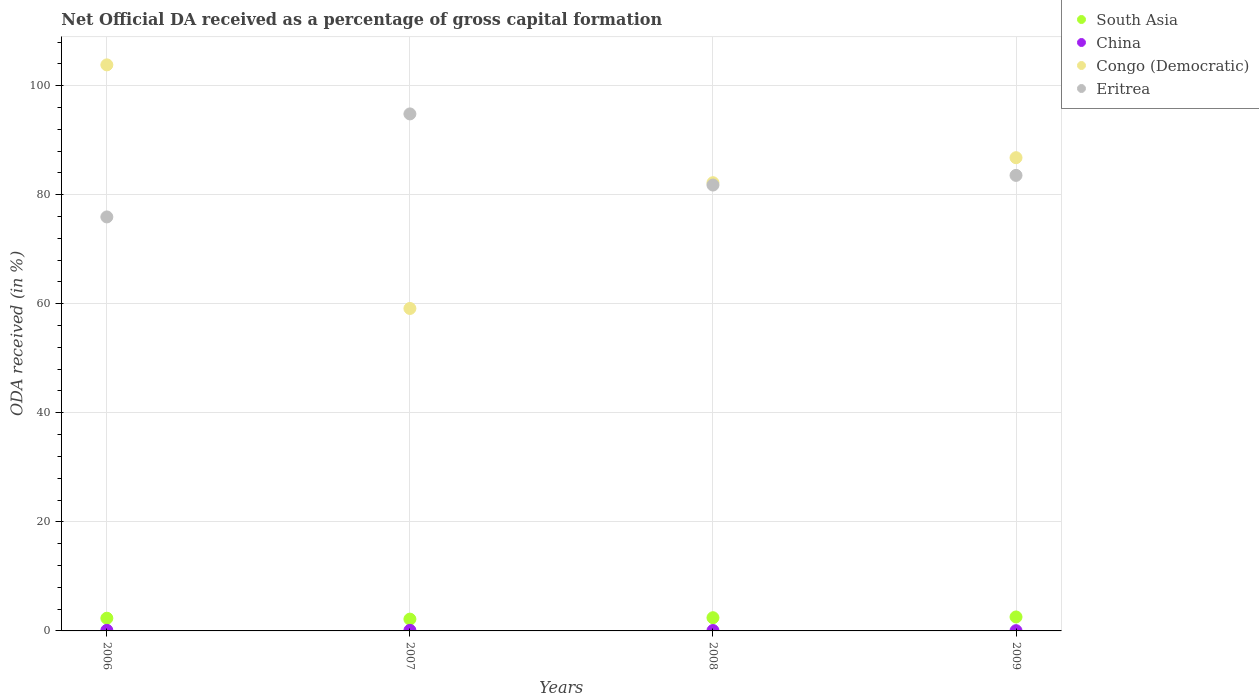How many different coloured dotlines are there?
Your response must be concise. 4. What is the net ODA received in China in 2009?
Provide a succinct answer. 0.05. Across all years, what is the maximum net ODA received in Eritrea?
Provide a short and direct response. 94.81. Across all years, what is the minimum net ODA received in Congo (Democratic)?
Offer a very short reply. 59.13. In which year was the net ODA received in Congo (Democratic) minimum?
Give a very brief answer. 2007. What is the total net ODA received in China in the graph?
Keep it short and to the point. 0.33. What is the difference between the net ODA received in China in 2006 and that in 2008?
Keep it short and to the point. 0.03. What is the difference between the net ODA received in Congo (Democratic) in 2006 and the net ODA received in South Asia in 2009?
Offer a very short reply. 101.25. What is the average net ODA received in China per year?
Offer a terse response. 0.08. In the year 2009, what is the difference between the net ODA received in Eritrea and net ODA received in China?
Your answer should be very brief. 83.49. What is the ratio of the net ODA received in Eritrea in 2008 to that in 2009?
Provide a succinct answer. 0.98. What is the difference between the highest and the second highest net ODA received in South Asia?
Keep it short and to the point. 0.14. What is the difference between the highest and the lowest net ODA received in Eritrea?
Provide a short and direct response. 18.89. In how many years, is the net ODA received in Eritrea greater than the average net ODA received in Eritrea taken over all years?
Make the answer very short. 1. Is the sum of the net ODA received in Eritrea in 2006 and 2007 greater than the maximum net ODA received in China across all years?
Offer a very short reply. Yes. Is it the case that in every year, the sum of the net ODA received in Congo (Democratic) and net ODA received in China  is greater than the sum of net ODA received in South Asia and net ODA received in Eritrea?
Your answer should be compact. Yes. Is the net ODA received in Congo (Democratic) strictly greater than the net ODA received in South Asia over the years?
Keep it short and to the point. Yes. How many dotlines are there?
Your response must be concise. 4. Does the graph contain any zero values?
Your response must be concise. No. Where does the legend appear in the graph?
Keep it short and to the point. Top right. What is the title of the graph?
Make the answer very short. Net Official DA received as a percentage of gross capital formation. What is the label or title of the X-axis?
Your answer should be very brief. Years. What is the label or title of the Y-axis?
Offer a very short reply. ODA received (in %). What is the ODA received (in %) of South Asia in 2006?
Offer a terse response. 2.33. What is the ODA received (in %) of China in 2006?
Your answer should be compact. 0.11. What is the ODA received (in %) in Congo (Democratic) in 2006?
Give a very brief answer. 103.81. What is the ODA received (in %) of Eritrea in 2006?
Your response must be concise. 75.92. What is the ODA received (in %) in South Asia in 2007?
Your answer should be compact. 2.16. What is the ODA received (in %) in China in 2007?
Give a very brief answer. 0.1. What is the ODA received (in %) of Congo (Democratic) in 2007?
Ensure brevity in your answer.  59.13. What is the ODA received (in %) in Eritrea in 2007?
Give a very brief answer. 94.81. What is the ODA received (in %) in South Asia in 2008?
Give a very brief answer. 2.42. What is the ODA received (in %) of China in 2008?
Your answer should be very brief. 0.07. What is the ODA received (in %) of Congo (Democratic) in 2008?
Provide a short and direct response. 82.2. What is the ODA received (in %) of Eritrea in 2008?
Provide a succinct answer. 81.77. What is the ODA received (in %) of South Asia in 2009?
Provide a short and direct response. 2.56. What is the ODA received (in %) in China in 2009?
Offer a terse response. 0.05. What is the ODA received (in %) in Congo (Democratic) in 2009?
Make the answer very short. 86.78. What is the ODA received (in %) of Eritrea in 2009?
Ensure brevity in your answer.  83.54. Across all years, what is the maximum ODA received (in %) in South Asia?
Offer a terse response. 2.56. Across all years, what is the maximum ODA received (in %) of China?
Provide a short and direct response. 0.11. Across all years, what is the maximum ODA received (in %) of Congo (Democratic)?
Offer a very short reply. 103.81. Across all years, what is the maximum ODA received (in %) of Eritrea?
Offer a terse response. 94.81. Across all years, what is the minimum ODA received (in %) in South Asia?
Give a very brief answer. 2.16. Across all years, what is the minimum ODA received (in %) of China?
Offer a very short reply. 0.05. Across all years, what is the minimum ODA received (in %) in Congo (Democratic)?
Offer a terse response. 59.13. Across all years, what is the minimum ODA received (in %) of Eritrea?
Keep it short and to the point. 75.92. What is the total ODA received (in %) in South Asia in the graph?
Your answer should be compact. 9.47. What is the total ODA received (in %) of China in the graph?
Ensure brevity in your answer.  0.33. What is the total ODA received (in %) of Congo (Democratic) in the graph?
Offer a terse response. 331.92. What is the total ODA received (in %) of Eritrea in the graph?
Your answer should be very brief. 336.04. What is the difference between the ODA received (in %) in South Asia in 2006 and that in 2007?
Your response must be concise. 0.17. What is the difference between the ODA received (in %) in China in 2006 and that in 2007?
Give a very brief answer. 0.01. What is the difference between the ODA received (in %) of Congo (Democratic) in 2006 and that in 2007?
Your answer should be compact. 44.67. What is the difference between the ODA received (in %) of Eritrea in 2006 and that in 2007?
Your answer should be compact. -18.89. What is the difference between the ODA received (in %) in South Asia in 2006 and that in 2008?
Give a very brief answer. -0.09. What is the difference between the ODA received (in %) in China in 2006 and that in 2008?
Provide a succinct answer. 0.03. What is the difference between the ODA received (in %) of Congo (Democratic) in 2006 and that in 2008?
Make the answer very short. 21.61. What is the difference between the ODA received (in %) in Eritrea in 2006 and that in 2008?
Provide a succinct answer. -5.85. What is the difference between the ODA received (in %) of South Asia in 2006 and that in 2009?
Your answer should be very brief. -0.23. What is the difference between the ODA received (in %) in China in 2006 and that in 2009?
Ensure brevity in your answer.  0.06. What is the difference between the ODA received (in %) of Congo (Democratic) in 2006 and that in 2009?
Provide a short and direct response. 17.02. What is the difference between the ODA received (in %) of Eritrea in 2006 and that in 2009?
Give a very brief answer. -7.62. What is the difference between the ODA received (in %) in South Asia in 2007 and that in 2008?
Keep it short and to the point. -0.26. What is the difference between the ODA received (in %) of China in 2007 and that in 2008?
Keep it short and to the point. 0.03. What is the difference between the ODA received (in %) of Congo (Democratic) in 2007 and that in 2008?
Keep it short and to the point. -23.07. What is the difference between the ODA received (in %) in Eritrea in 2007 and that in 2008?
Ensure brevity in your answer.  13.04. What is the difference between the ODA received (in %) in South Asia in 2007 and that in 2009?
Offer a terse response. -0.4. What is the difference between the ODA received (in %) in China in 2007 and that in 2009?
Your answer should be compact. 0.06. What is the difference between the ODA received (in %) in Congo (Democratic) in 2007 and that in 2009?
Your answer should be compact. -27.65. What is the difference between the ODA received (in %) of Eritrea in 2007 and that in 2009?
Your answer should be compact. 11.27. What is the difference between the ODA received (in %) of South Asia in 2008 and that in 2009?
Make the answer very short. -0.14. What is the difference between the ODA received (in %) in China in 2008 and that in 2009?
Offer a terse response. 0.03. What is the difference between the ODA received (in %) of Congo (Democratic) in 2008 and that in 2009?
Make the answer very short. -4.59. What is the difference between the ODA received (in %) in Eritrea in 2008 and that in 2009?
Keep it short and to the point. -1.77. What is the difference between the ODA received (in %) in South Asia in 2006 and the ODA received (in %) in China in 2007?
Provide a short and direct response. 2.23. What is the difference between the ODA received (in %) in South Asia in 2006 and the ODA received (in %) in Congo (Democratic) in 2007?
Offer a very short reply. -56.8. What is the difference between the ODA received (in %) in South Asia in 2006 and the ODA received (in %) in Eritrea in 2007?
Ensure brevity in your answer.  -92.48. What is the difference between the ODA received (in %) of China in 2006 and the ODA received (in %) of Congo (Democratic) in 2007?
Keep it short and to the point. -59.03. What is the difference between the ODA received (in %) in China in 2006 and the ODA received (in %) in Eritrea in 2007?
Keep it short and to the point. -94.71. What is the difference between the ODA received (in %) of Congo (Democratic) in 2006 and the ODA received (in %) of Eritrea in 2007?
Your answer should be very brief. 8.99. What is the difference between the ODA received (in %) in South Asia in 2006 and the ODA received (in %) in China in 2008?
Your answer should be very brief. 2.25. What is the difference between the ODA received (in %) in South Asia in 2006 and the ODA received (in %) in Congo (Democratic) in 2008?
Make the answer very short. -79.87. What is the difference between the ODA received (in %) in South Asia in 2006 and the ODA received (in %) in Eritrea in 2008?
Your answer should be very brief. -79.44. What is the difference between the ODA received (in %) in China in 2006 and the ODA received (in %) in Congo (Democratic) in 2008?
Your answer should be compact. -82.09. What is the difference between the ODA received (in %) in China in 2006 and the ODA received (in %) in Eritrea in 2008?
Your answer should be very brief. -81.66. What is the difference between the ODA received (in %) of Congo (Democratic) in 2006 and the ODA received (in %) of Eritrea in 2008?
Your response must be concise. 22.04. What is the difference between the ODA received (in %) of South Asia in 2006 and the ODA received (in %) of China in 2009?
Keep it short and to the point. 2.28. What is the difference between the ODA received (in %) in South Asia in 2006 and the ODA received (in %) in Congo (Democratic) in 2009?
Your answer should be very brief. -84.45. What is the difference between the ODA received (in %) of South Asia in 2006 and the ODA received (in %) of Eritrea in 2009?
Keep it short and to the point. -81.21. What is the difference between the ODA received (in %) of China in 2006 and the ODA received (in %) of Congo (Democratic) in 2009?
Ensure brevity in your answer.  -86.68. What is the difference between the ODA received (in %) of China in 2006 and the ODA received (in %) of Eritrea in 2009?
Your answer should be very brief. -83.43. What is the difference between the ODA received (in %) in Congo (Democratic) in 2006 and the ODA received (in %) in Eritrea in 2009?
Your response must be concise. 20.27. What is the difference between the ODA received (in %) in South Asia in 2007 and the ODA received (in %) in China in 2008?
Ensure brevity in your answer.  2.09. What is the difference between the ODA received (in %) in South Asia in 2007 and the ODA received (in %) in Congo (Democratic) in 2008?
Make the answer very short. -80.03. What is the difference between the ODA received (in %) of South Asia in 2007 and the ODA received (in %) of Eritrea in 2008?
Your answer should be very brief. -79.6. What is the difference between the ODA received (in %) of China in 2007 and the ODA received (in %) of Congo (Democratic) in 2008?
Your answer should be very brief. -82.1. What is the difference between the ODA received (in %) in China in 2007 and the ODA received (in %) in Eritrea in 2008?
Give a very brief answer. -81.67. What is the difference between the ODA received (in %) in Congo (Democratic) in 2007 and the ODA received (in %) in Eritrea in 2008?
Your response must be concise. -22.64. What is the difference between the ODA received (in %) of South Asia in 2007 and the ODA received (in %) of China in 2009?
Offer a terse response. 2.12. What is the difference between the ODA received (in %) of South Asia in 2007 and the ODA received (in %) of Congo (Democratic) in 2009?
Your answer should be very brief. -84.62. What is the difference between the ODA received (in %) of South Asia in 2007 and the ODA received (in %) of Eritrea in 2009?
Your response must be concise. -81.38. What is the difference between the ODA received (in %) of China in 2007 and the ODA received (in %) of Congo (Democratic) in 2009?
Keep it short and to the point. -86.68. What is the difference between the ODA received (in %) in China in 2007 and the ODA received (in %) in Eritrea in 2009?
Make the answer very short. -83.44. What is the difference between the ODA received (in %) of Congo (Democratic) in 2007 and the ODA received (in %) of Eritrea in 2009?
Provide a succinct answer. -24.41. What is the difference between the ODA received (in %) of South Asia in 2008 and the ODA received (in %) of China in 2009?
Make the answer very short. 2.37. What is the difference between the ODA received (in %) of South Asia in 2008 and the ODA received (in %) of Congo (Democratic) in 2009?
Ensure brevity in your answer.  -84.36. What is the difference between the ODA received (in %) of South Asia in 2008 and the ODA received (in %) of Eritrea in 2009?
Offer a very short reply. -81.12. What is the difference between the ODA received (in %) in China in 2008 and the ODA received (in %) in Congo (Democratic) in 2009?
Provide a short and direct response. -86.71. What is the difference between the ODA received (in %) of China in 2008 and the ODA received (in %) of Eritrea in 2009?
Your answer should be compact. -83.47. What is the difference between the ODA received (in %) of Congo (Democratic) in 2008 and the ODA received (in %) of Eritrea in 2009?
Make the answer very short. -1.34. What is the average ODA received (in %) of South Asia per year?
Your answer should be compact. 2.37. What is the average ODA received (in %) in China per year?
Ensure brevity in your answer.  0.08. What is the average ODA received (in %) of Congo (Democratic) per year?
Provide a succinct answer. 82.98. What is the average ODA received (in %) in Eritrea per year?
Provide a short and direct response. 84.01. In the year 2006, what is the difference between the ODA received (in %) in South Asia and ODA received (in %) in China?
Your response must be concise. 2.22. In the year 2006, what is the difference between the ODA received (in %) in South Asia and ODA received (in %) in Congo (Democratic)?
Offer a very short reply. -101.48. In the year 2006, what is the difference between the ODA received (in %) of South Asia and ODA received (in %) of Eritrea?
Ensure brevity in your answer.  -73.59. In the year 2006, what is the difference between the ODA received (in %) of China and ODA received (in %) of Congo (Democratic)?
Offer a terse response. -103.7. In the year 2006, what is the difference between the ODA received (in %) of China and ODA received (in %) of Eritrea?
Give a very brief answer. -75.81. In the year 2006, what is the difference between the ODA received (in %) in Congo (Democratic) and ODA received (in %) in Eritrea?
Give a very brief answer. 27.89. In the year 2007, what is the difference between the ODA received (in %) of South Asia and ODA received (in %) of China?
Offer a terse response. 2.06. In the year 2007, what is the difference between the ODA received (in %) in South Asia and ODA received (in %) in Congo (Democratic)?
Make the answer very short. -56.97. In the year 2007, what is the difference between the ODA received (in %) of South Asia and ODA received (in %) of Eritrea?
Your answer should be very brief. -92.65. In the year 2007, what is the difference between the ODA received (in %) of China and ODA received (in %) of Congo (Democratic)?
Give a very brief answer. -59.03. In the year 2007, what is the difference between the ODA received (in %) in China and ODA received (in %) in Eritrea?
Make the answer very short. -94.71. In the year 2007, what is the difference between the ODA received (in %) of Congo (Democratic) and ODA received (in %) of Eritrea?
Make the answer very short. -35.68. In the year 2008, what is the difference between the ODA received (in %) of South Asia and ODA received (in %) of China?
Ensure brevity in your answer.  2.35. In the year 2008, what is the difference between the ODA received (in %) in South Asia and ODA received (in %) in Congo (Democratic)?
Keep it short and to the point. -79.78. In the year 2008, what is the difference between the ODA received (in %) of South Asia and ODA received (in %) of Eritrea?
Your response must be concise. -79.35. In the year 2008, what is the difference between the ODA received (in %) in China and ODA received (in %) in Congo (Democratic)?
Keep it short and to the point. -82.12. In the year 2008, what is the difference between the ODA received (in %) in China and ODA received (in %) in Eritrea?
Keep it short and to the point. -81.69. In the year 2008, what is the difference between the ODA received (in %) of Congo (Democratic) and ODA received (in %) of Eritrea?
Your answer should be compact. 0.43. In the year 2009, what is the difference between the ODA received (in %) in South Asia and ODA received (in %) in China?
Ensure brevity in your answer.  2.51. In the year 2009, what is the difference between the ODA received (in %) in South Asia and ODA received (in %) in Congo (Democratic)?
Keep it short and to the point. -84.22. In the year 2009, what is the difference between the ODA received (in %) of South Asia and ODA received (in %) of Eritrea?
Provide a short and direct response. -80.98. In the year 2009, what is the difference between the ODA received (in %) of China and ODA received (in %) of Congo (Democratic)?
Offer a terse response. -86.74. In the year 2009, what is the difference between the ODA received (in %) in China and ODA received (in %) in Eritrea?
Offer a terse response. -83.49. In the year 2009, what is the difference between the ODA received (in %) in Congo (Democratic) and ODA received (in %) in Eritrea?
Your answer should be compact. 3.24. What is the ratio of the ODA received (in %) of South Asia in 2006 to that in 2007?
Ensure brevity in your answer.  1.08. What is the ratio of the ODA received (in %) of China in 2006 to that in 2007?
Provide a short and direct response. 1.05. What is the ratio of the ODA received (in %) of Congo (Democratic) in 2006 to that in 2007?
Offer a terse response. 1.76. What is the ratio of the ODA received (in %) of Eritrea in 2006 to that in 2007?
Provide a short and direct response. 0.8. What is the ratio of the ODA received (in %) in South Asia in 2006 to that in 2008?
Offer a very short reply. 0.96. What is the ratio of the ODA received (in %) of China in 2006 to that in 2008?
Your response must be concise. 1.44. What is the ratio of the ODA received (in %) in Congo (Democratic) in 2006 to that in 2008?
Your answer should be compact. 1.26. What is the ratio of the ODA received (in %) of Eritrea in 2006 to that in 2008?
Provide a short and direct response. 0.93. What is the ratio of the ODA received (in %) in South Asia in 2006 to that in 2009?
Make the answer very short. 0.91. What is the ratio of the ODA received (in %) in China in 2006 to that in 2009?
Ensure brevity in your answer.  2.28. What is the ratio of the ODA received (in %) of Congo (Democratic) in 2006 to that in 2009?
Your response must be concise. 1.2. What is the ratio of the ODA received (in %) in Eritrea in 2006 to that in 2009?
Your answer should be very brief. 0.91. What is the ratio of the ODA received (in %) in South Asia in 2007 to that in 2008?
Give a very brief answer. 0.89. What is the ratio of the ODA received (in %) in China in 2007 to that in 2008?
Keep it short and to the point. 1.37. What is the ratio of the ODA received (in %) of Congo (Democratic) in 2007 to that in 2008?
Provide a succinct answer. 0.72. What is the ratio of the ODA received (in %) in Eritrea in 2007 to that in 2008?
Your answer should be compact. 1.16. What is the ratio of the ODA received (in %) of South Asia in 2007 to that in 2009?
Your answer should be compact. 0.84. What is the ratio of the ODA received (in %) of China in 2007 to that in 2009?
Offer a very short reply. 2.17. What is the ratio of the ODA received (in %) of Congo (Democratic) in 2007 to that in 2009?
Make the answer very short. 0.68. What is the ratio of the ODA received (in %) in Eritrea in 2007 to that in 2009?
Offer a very short reply. 1.13. What is the ratio of the ODA received (in %) of South Asia in 2008 to that in 2009?
Offer a terse response. 0.95. What is the ratio of the ODA received (in %) of China in 2008 to that in 2009?
Give a very brief answer. 1.58. What is the ratio of the ODA received (in %) of Congo (Democratic) in 2008 to that in 2009?
Ensure brevity in your answer.  0.95. What is the ratio of the ODA received (in %) of Eritrea in 2008 to that in 2009?
Give a very brief answer. 0.98. What is the difference between the highest and the second highest ODA received (in %) in South Asia?
Provide a succinct answer. 0.14. What is the difference between the highest and the second highest ODA received (in %) in China?
Ensure brevity in your answer.  0.01. What is the difference between the highest and the second highest ODA received (in %) in Congo (Democratic)?
Offer a very short reply. 17.02. What is the difference between the highest and the second highest ODA received (in %) of Eritrea?
Keep it short and to the point. 11.27. What is the difference between the highest and the lowest ODA received (in %) of South Asia?
Provide a succinct answer. 0.4. What is the difference between the highest and the lowest ODA received (in %) in China?
Your answer should be compact. 0.06. What is the difference between the highest and the lowest ODA received (in %) of Congo (Democratic)?
Provide a succinct answer. 44.67. What is the difference between the highest and the lowest ODA received (in %) of Eritrea?
Make the answer very short. 18.89. 